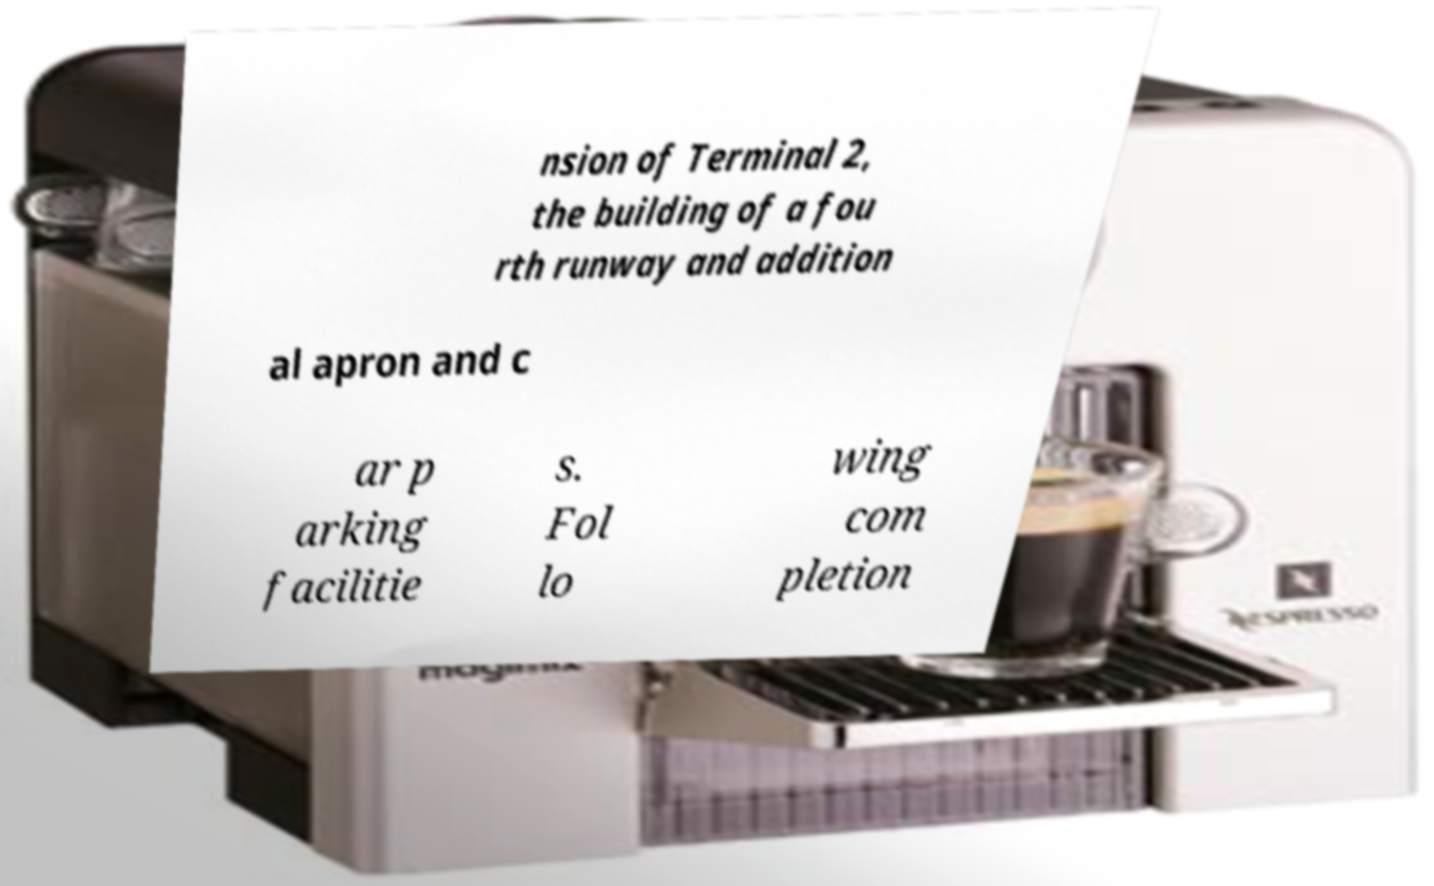For documentation purposes, I need the text within this image transcribed. Could you provide that? nsion of Terminal 2, the building of a fou rth runway and addition al apron and c ar p arking facilitie s. Fol lo wing com pletion 